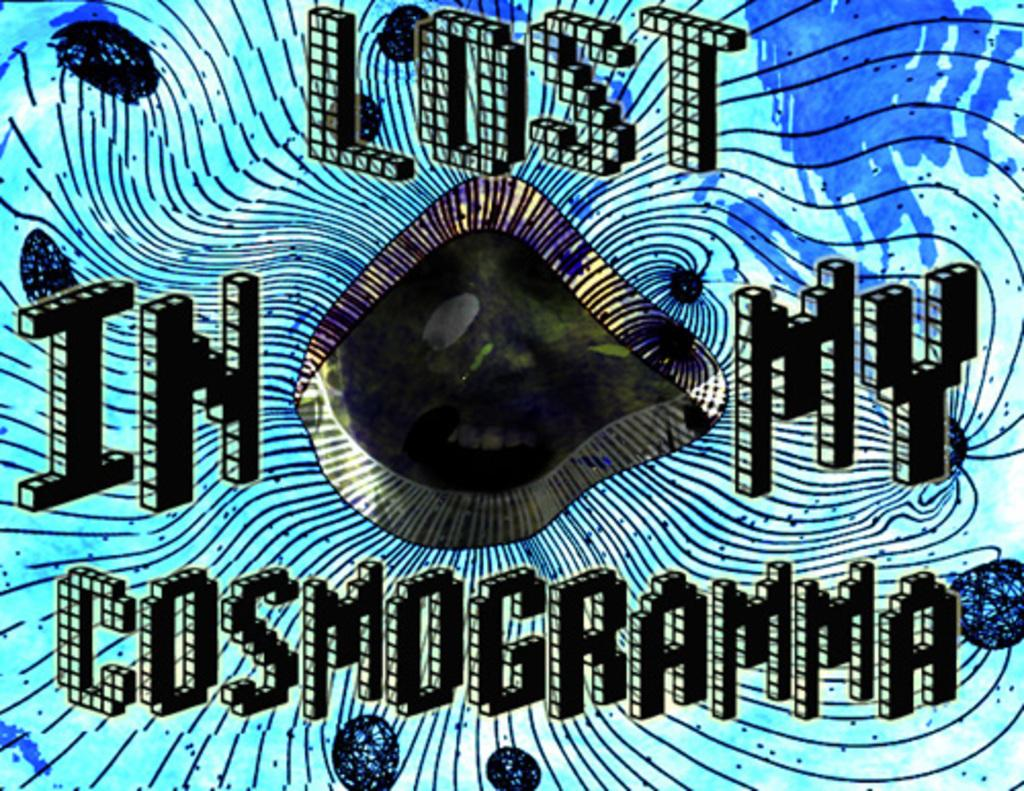What type of image is being described? The image is graphical in nature. What color is the text in the image? The text in the image is written in black color. What color is the background of the image? The background of the image is blue in color. Can you see any part of a sail in the image? There is no sail present in the image; it is a graphical image with text and a blue background. 